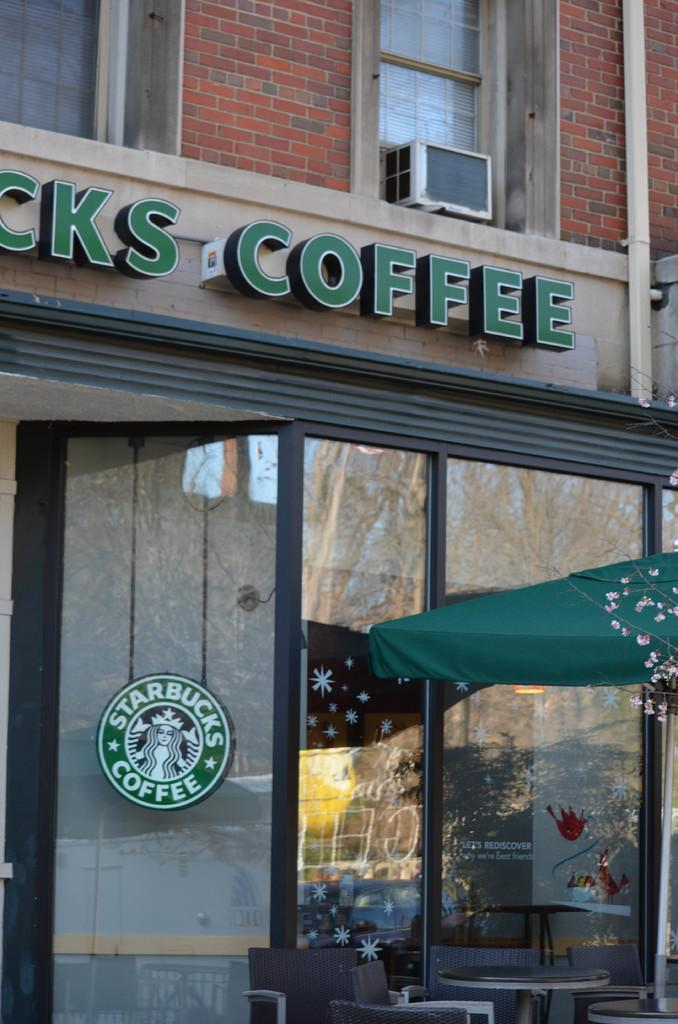What type of structure is visible in the image? There is a part of a building in the image. What is located on the right side of the image? There is a tent on the right side of the image. What piece of furniture can be seen in the image? There is a table in the image. What type of seating is present in the image? There are chairs in the image. What type of watch is the patch on the building referring to in the image? There is no watch or patch present in the image. 